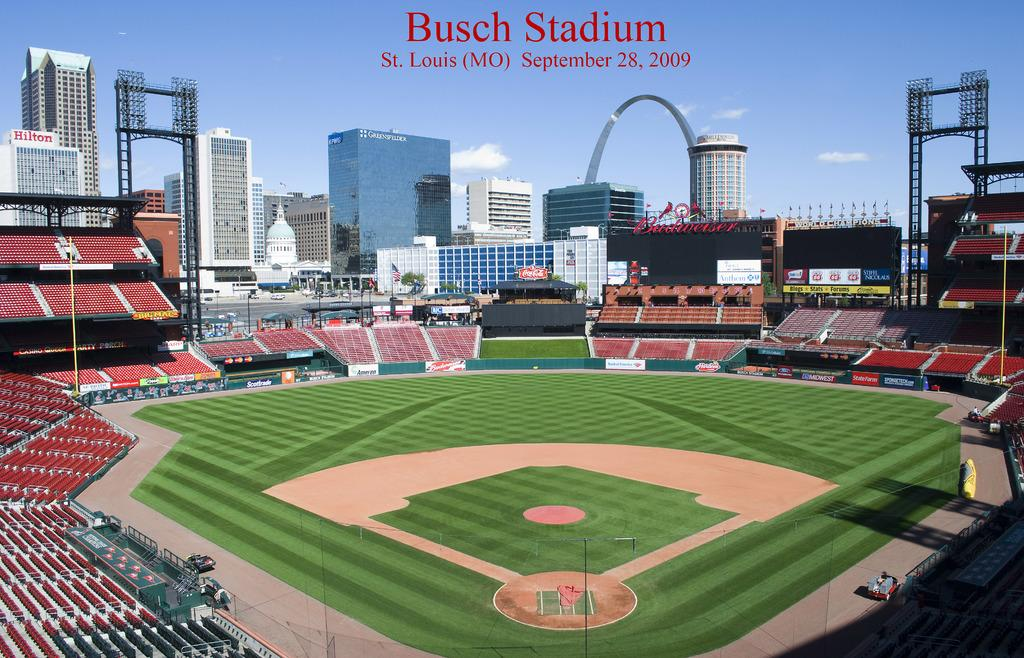<image>
Offer a succinct explanation of the picture presented. The stands are completely empty in what looks like a perfect day at Busch Stadium. 